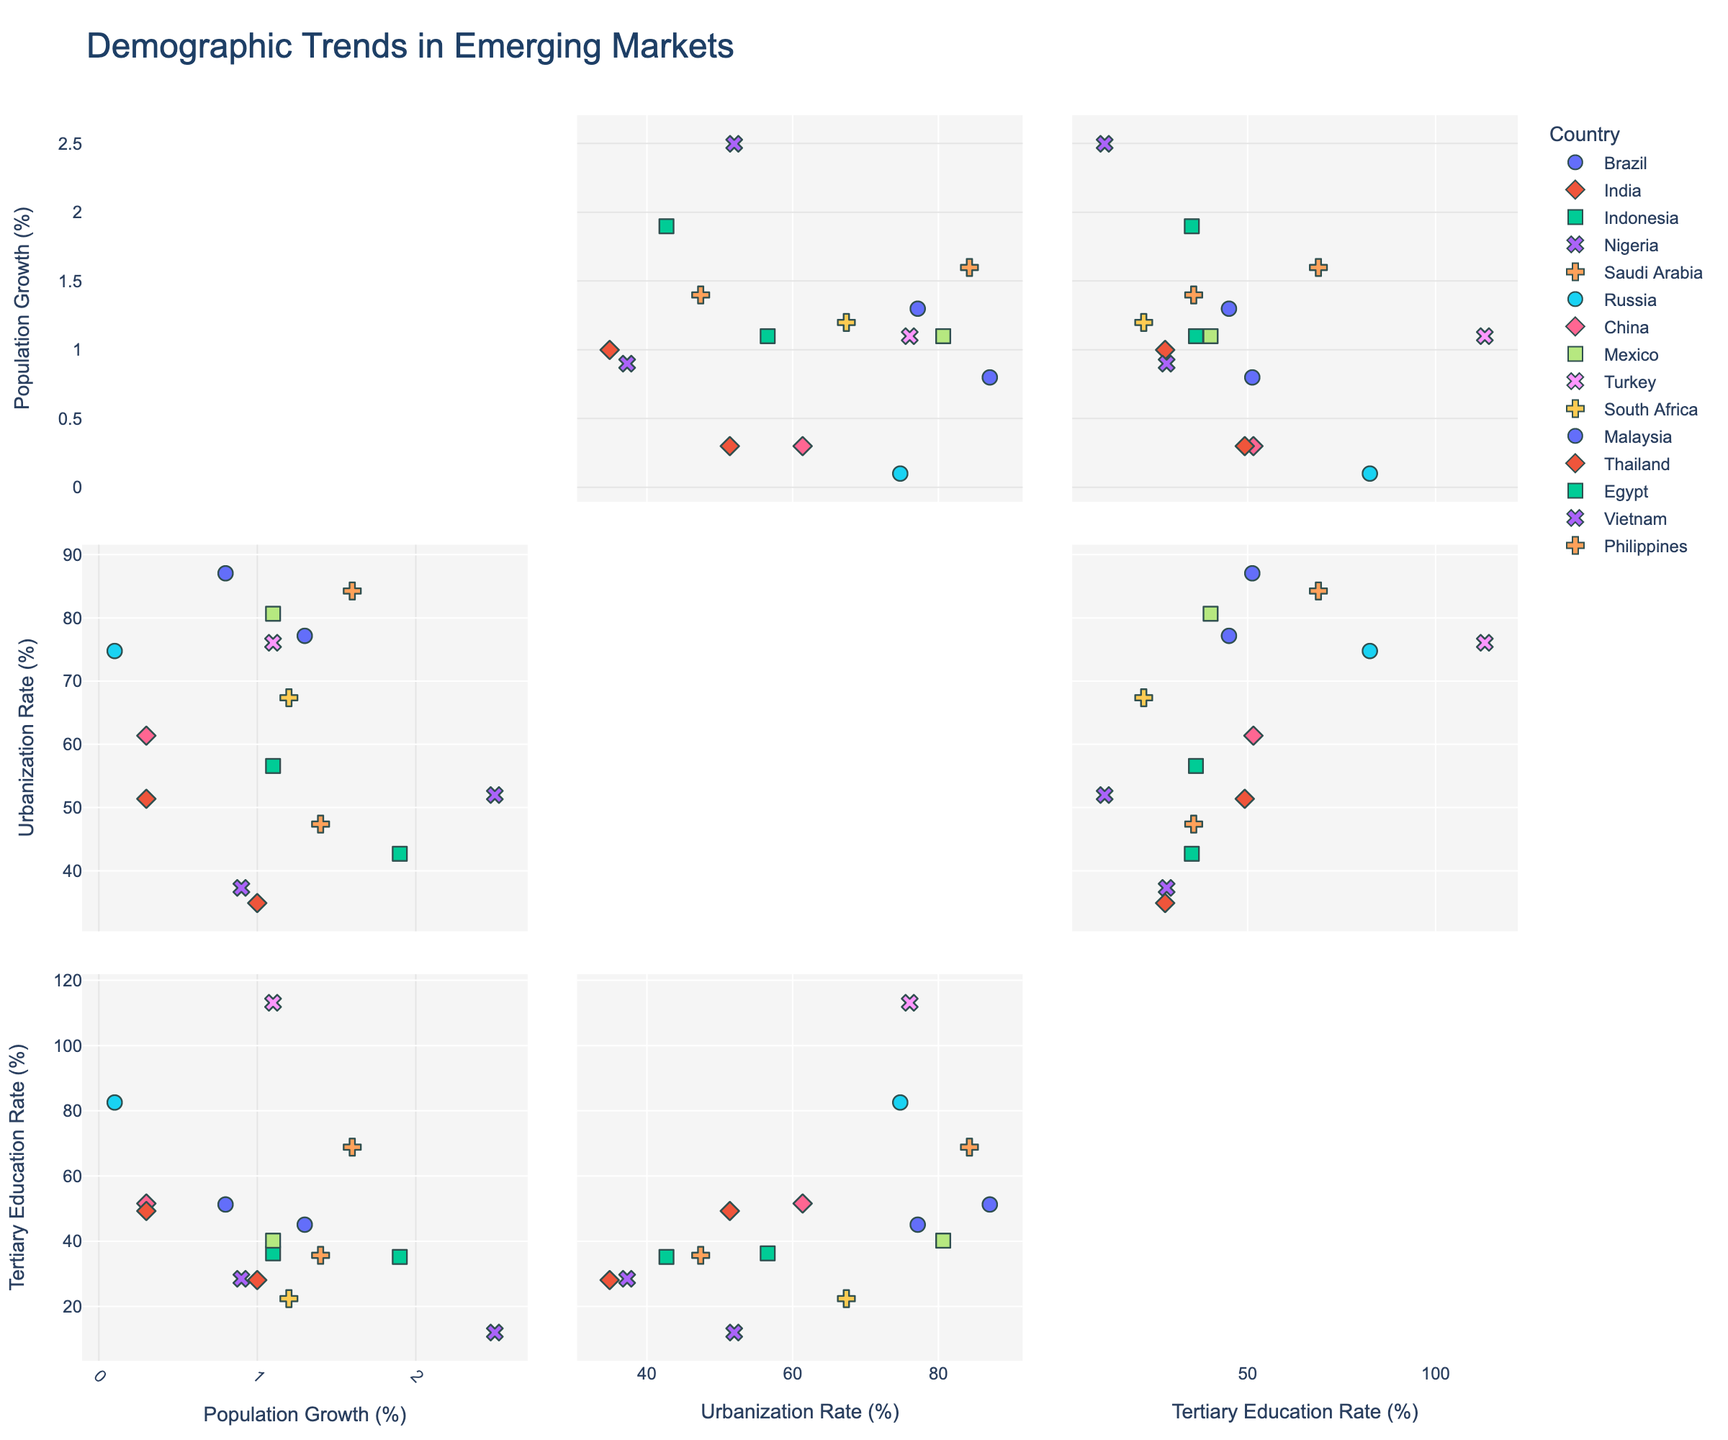What is the title of the figure? The title is usually placed at the top of the figure. It provides a brief description of the content and insights the figure aims to convey.
Answer: Demographic Trends in Emerging Markets How many dimensions are represented in each subplot of the scatterplot matrix? By examining each subplot, one can see that each represents data distributions between pairs of three different variables.
Answer: Three Which country has the highest population growth rate? Locate the data points along the 'Population Growth' axis and find the one with the highest value.
Answer: Nigeria What is the urbanization rate for Indonesia? Find Indonesia on the scatterplots and read the value corresponding to the 'Urbanization Rate' axis.
Answer: 56.6% Which country has the highest tertiary education rate? Scan the scatterplots to identify the highest value on the 'Tertiary Education Rate' axis.
Answer: Turkey Compare the urbanization rates of Brazil and Nigeria. Which is higher? Find Brazil and Nigeria on the scatterplots and compare their positions on the 'Urbanization Rate' axis.
Answer: Brazil Is there a correlation between population growth and urbanization rate in the countries shown? Observe the scatterplots comparing 'Population Growth' with 'Urbanization Rate' to identify any trend or pattern.
Answer: No strong correlation Which country has a higher tertiary education rate, India or Malaysia? Find India and Malaysia on the scatterplots and compare their positions on the 'Tertiary Education Rate' axis.
Answer: Malaysia What is the relationship between tertiary education rate and urbanization rate for South Africa? Locate South Africa on the scatterplots that compare 'Tertiary Education Rate' and 'Urbanization Rate' to identify any visible pattern.
Answer: Moderate correlation How does the population growth of Egypt compare to that of Vietnam? Find Egypt and Vietnam on the scatterplots and compare their values along the 'Population Growth' axis.
Answer: Egypt's population growth is higher 